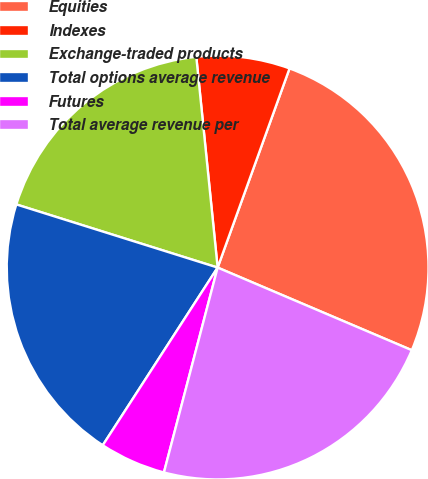Convert chart to OTSL. <chart><loc_0><loc_0><loc_500><loc_500><pie_chart><fcel>Equities<fcel>Indexes<fcel>Exchange-traded products<fcel>Total options average revenue<fcel>Futures<fcel>Total average revenue per<nl><fcel>25.84%<fcel>7.15%<fcel>18.57%<fcel>20.65%<fcel>5.07%<fcel>22.72%<nl></chart> 